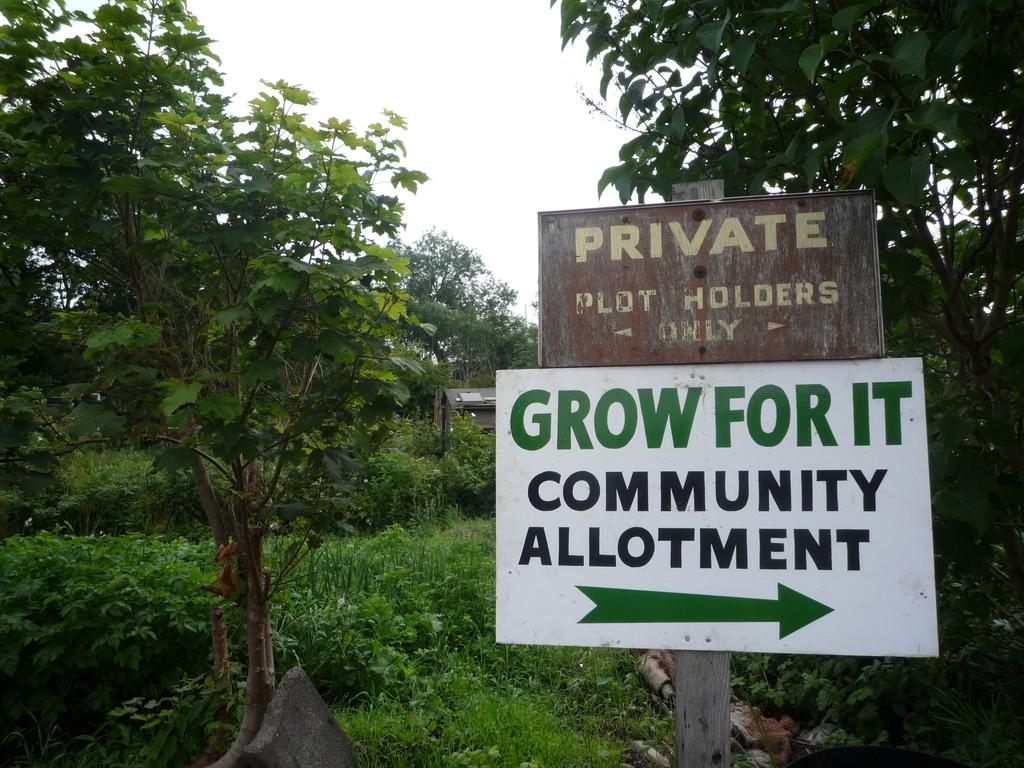What type of vegetation can be seen in the image? There are trees in the image. What else is present in the image besides the trees? There are two boards with text in the image. What is visible at the top of the image? The sky is visible at the top of the image. Can you tell me how many sponges are hanging from the trees in the image? There are no sponges present in the user text directly without any additional interjections. 